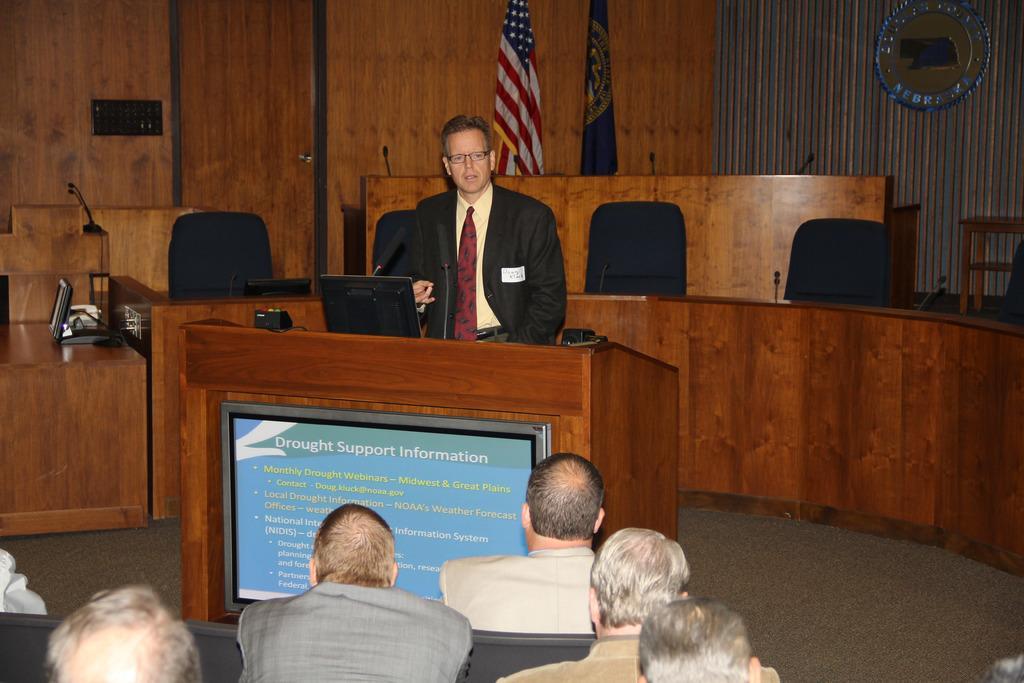In one or two sentences, can you explain what this image depicts? In the foreground of the picture there are people sitting in chairs. In the middle of the picture there is a person standing in front of the desk, on the desk there are some electronic gadgets. In the background there are chairs, desk, flags, wall and other objects. 